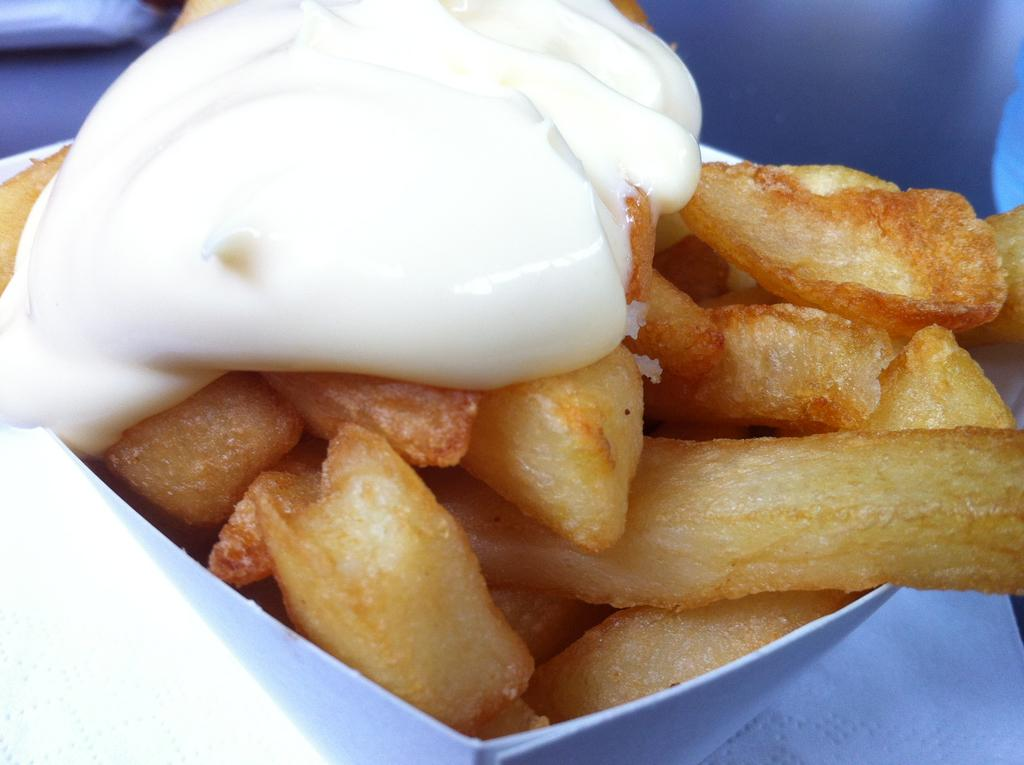What object is visible in the image that contains food? There is a box in the image that contains food. What type of food is inside the box? French fries are present in the box. What condiment is also present in the box? Mayonnaise is present in the box. What type of coat is hanging on the wall in the image? There is no coat present in the image; it only features a box with French fries and mayonnaise. 